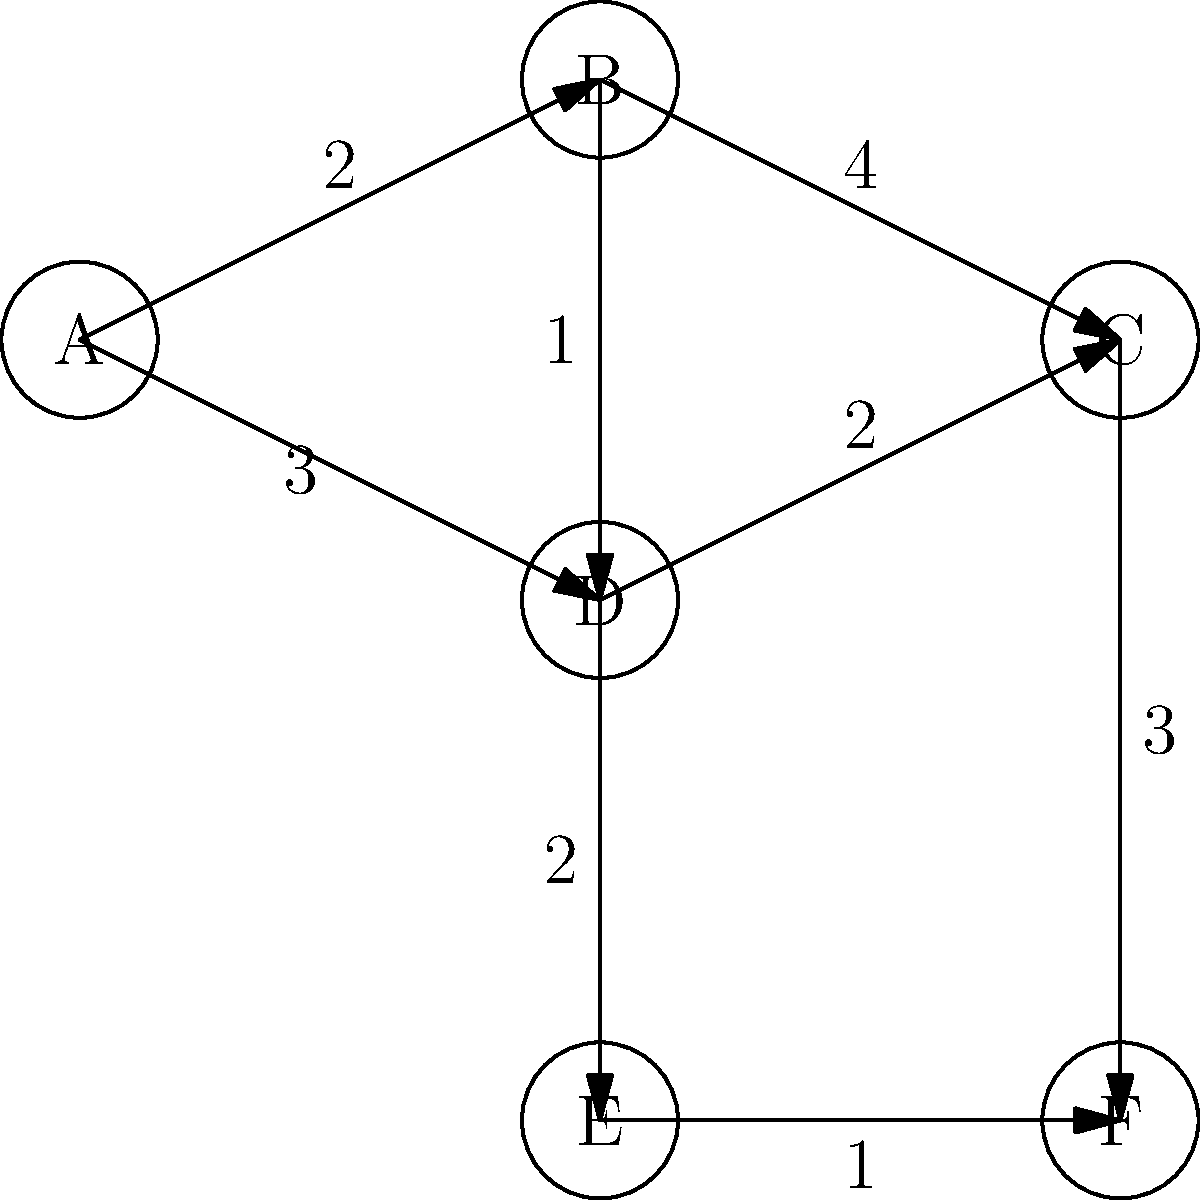In the directed graph representing system log sequences, nodes represent critical events and edges represent the time (in minutes) between events. What is the shortest path from event A to event F, and what is the total time taken along this path? To find the shortest path from A to F, we need to consider all possible paths and their total times:

1. Path A → B → C → F:
   Time = 2 + 4 + 3 = 9 minutes

2. Path A → B → D → C → F:
   Time = 2 + 1 + 2 + 3 = 8 minutes

3. Path A → D → C → F:
   Time = 3 + 2 + 3 = 8 minutes

4. Path A → D → E → F:
   Time = 3 + 2 + 1 = 6 minutes

The shortest path is A → D → E → F, with a total time of 6 minutes.

To verify this result, we can use Dijkstra's algorithm:
1. Start at A (distance 0)
2. Update neighbors of A: B (2), D (3)
3. Visit B (2): Update C (6), D (3 remains)
4. Visit D (3): Update C (5), E (5)
5. Visit E (5): Update F (6)
6. Visit C (5): Update F (8)
7. Visit F (6): End

This confirms that the shortest path to F is indeed 6 minutes long.
Answer: A → D → E → F, 6 minutes 